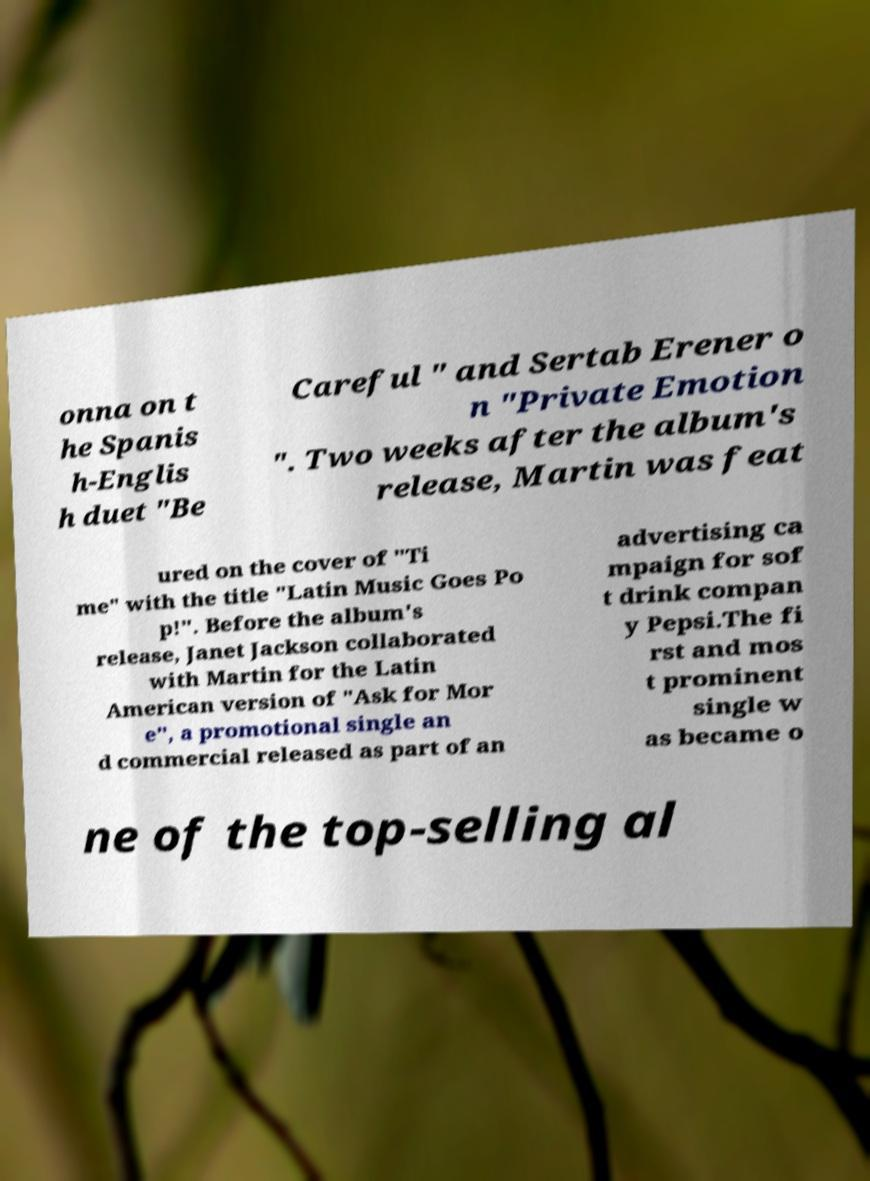There's text embedded in this image that I need extracted. Can you transcribe it verbatim? onna on t he Spanis h-Englis h duet "Be Careful " and Sertab Erener o n "Private Emotion ". Two weeks after the album's release, Martin was feat ured on the cover of "Ti me" with the title "Latin Music Goes Po p!". Before the album's release, Janet Jackson collaborated with Martin for the Latin American version of "Ask for Mor e", a promotional single an d commercial released as part of an advertising ca mpaign for sof t drink compan y Pepsi.The fi rst and mos t prominent single w as became o ne of the top-selling al 